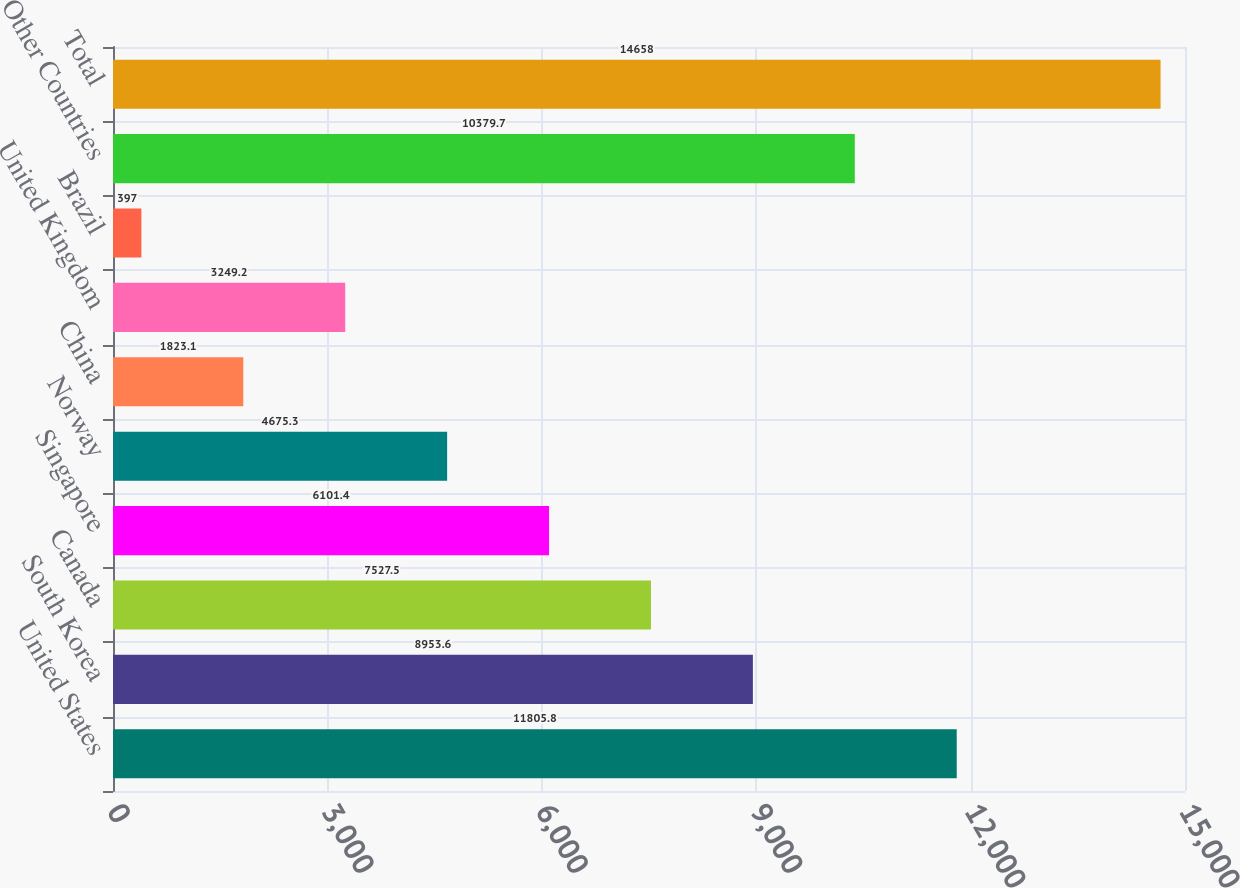Convert chart to OTSL. <chart><loc_0><loc_0><loc_500><loc_500><bar_chart><fcel>United States<fcel>South Korea<fcel>Canada<fcel>Singapore<fcel>Norway<fcel>China<fcel>United Kingdom<fcel>Brazil<fcel>Other Countries<fcel>Total<nl><fcel>11805.8<fcel>8953.6<fcel>7527.5<fcel>6101.4<fcel>4675.3<fcel>1823.1<fcel>3249.2<fcel>397<fcel>10379.7<fcel>14658<nl></chart> 